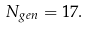<formula> <loc_0><loc_0><loc_500><loc_500>N _ { g e n } = 1 7 .</formula> 